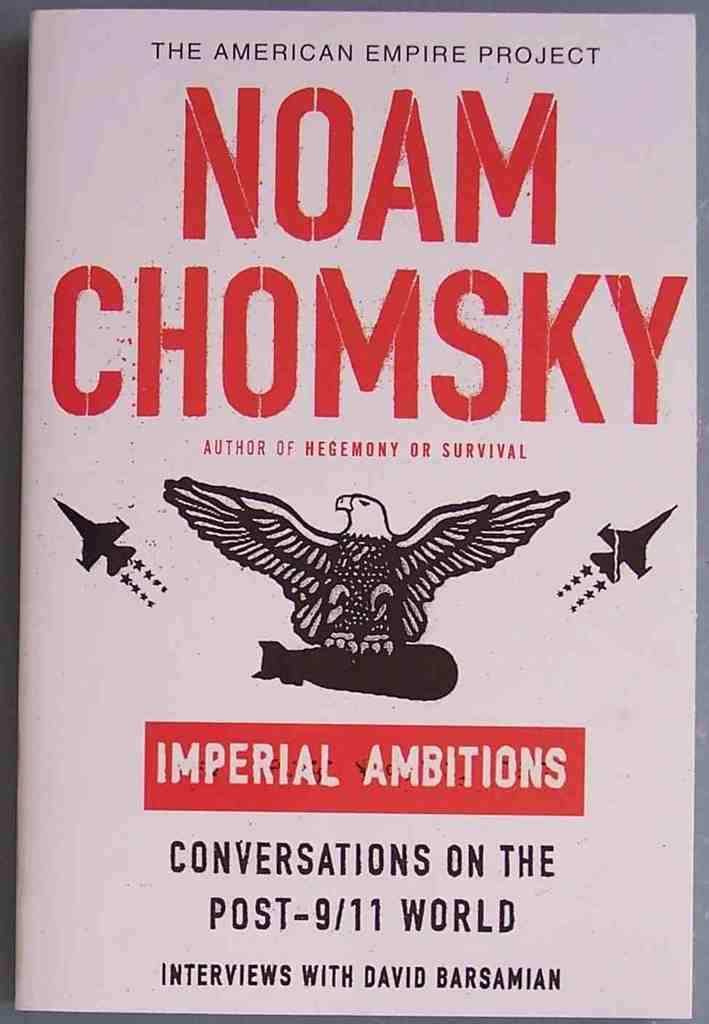What is featured on the poster in the image? The poster contains words, numbers, photos of two aircrafts, and a photo of an eagle. Can you describe the content of the poster in more detail? The poster contains a combination of text, numbers, and images, including photos of two aircrafts and an eagle. How does the poster increase the value of the items in the shop? The poster does not increase the value of any items in a shop, as it is a visual representation of information and not a physical object. 